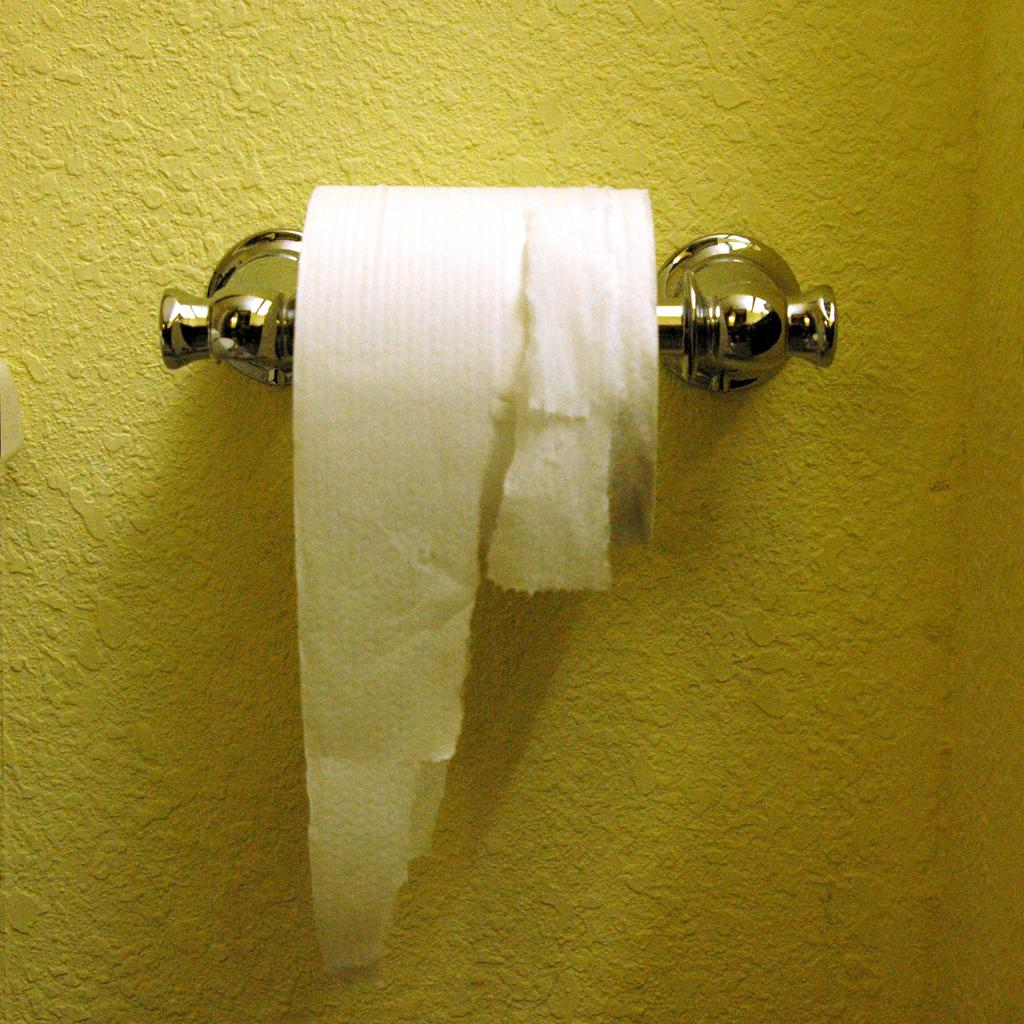What object is designed to hold tissue paper in the image? There is a tissue paper holder in the image. What is inside the tissue paper holder? There is a tissue paper roll in the image. What color is the wall that the tissue paper holder and roll are attached to? The tissue paper holder and roll are attached to a yellow wall. How many bridges can be seen in the image? There are no bridges present in the image. What is the attention-grabbing feature of the tissue paper holder in the image? The tissue paper holder does not have any attention-grabbing features in the image; it is a functional object designed to hold tissue paper. 